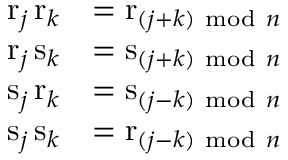Convert formula to latex. <formula><loc_0><loc_0><loc_500><loc_500>{ \begin{array} { r l } { r _ { j } \, r _ { k } } & { = r _ { ( j + k ) { m o d } n } } \\ { r _ { j } \, s _ { k } } & { = s _ { ( j + k ) { m o d } n } } \\ { s _ { j } \, r _ { k } } & { = s _ { ( j - k ) { m o d } n } } \\ { s _ { j } \, s _ { k } } & { = r _ { ( j - k ) { m o d } n } } \end{array} }</formula> 